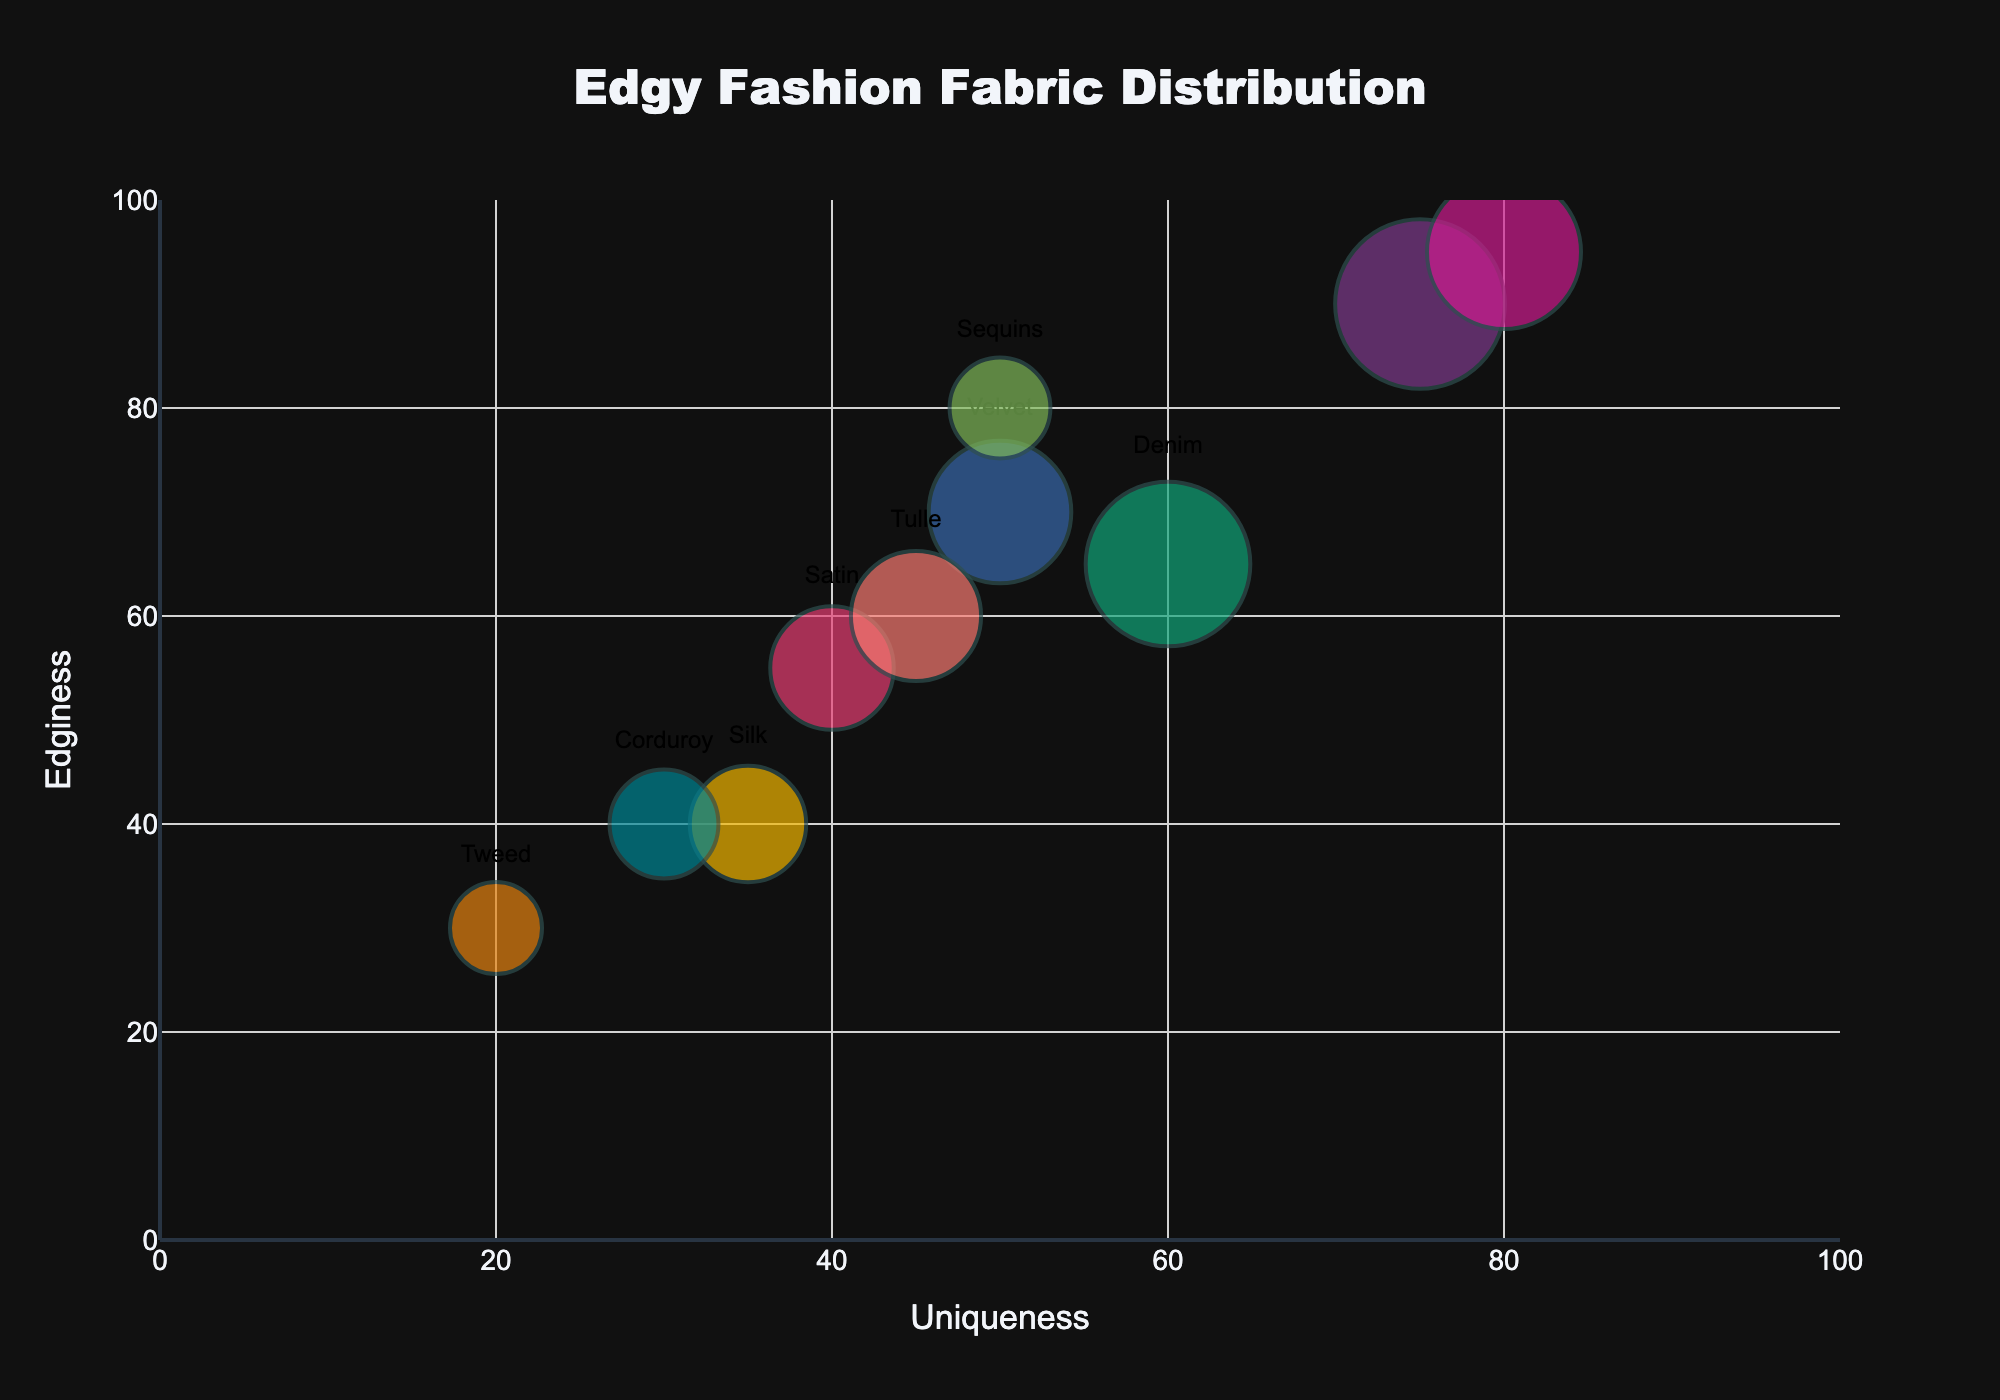what is the title of this Bubble Chart? The title is displayed prominently at the top center of the chart. It reads "Edgy Fashion Fabric Distribution".
Answer: Edgy Fashion Fabric Distribution how many fabrics are represented in this Bubble Chart? Count the number of unique bubbles in the chart. Each bubble represents a different fabric. There are 10 unique bubbles.
Answer: 10 which fabric has the highest popularity and what are its uniqueness and edginess values? Look for the largest bubble, as size indicates popularity. The largest bubble corresponds to Leather, with a popularity of 85, a uniqueness of 75, and an edginess of 90.
Answer: Leather, 75, 90 what is the average edginess value of the fabrics with a popularity greater than 50? Identify the fabrics with popularity values above 50: Leather, Denim, Velvet, Latex, and Tulle. Their edginess values are 90, 65, 70, 95, and 60 respectively. Calculate the average: (90 + 65 + 70 + 95 + 60) / 5 = 380 / 5 = 76.
Answer: 76 which fabric is less unique but more edgy than Denim? Find the bubble for Denim and note its uniqueness and edginess values: 60 and 65. Look for any bubble with a uniqueness less than 60 and an edginess more than 65. Sequins meets these criteria with a uniqueness of 50 and an edginess of 80.
Answer: Sequins how many fabrics have an edginess value greater than their uniqueness value? Compare the uniqueness and edginess values of all fabrics. Leather (75, 90), Sequins (50, 80), and Latex (80, 95) have edginess values greater than their uniqueness values. There are 3 such fabrics.
Answer: 3 which fabric with the lowest popularity has edginess and uniqueness values lower than 40? Identify the bubble with the smallest size, indicating the lowest popularity. Tweed has a popularity of 25, with edginess and uniqueness values of 30 and 20 respectively, both lower than 40.
Answer: Tweed is there any bubble that aligns with the same uniqueness and edginess value? Check if any two bubbles have the same uniqueness and edginess values. No bubbles have identical values for both attributes.
Answer: No which fabric has the same popularity level as Tulle but different uniqueness and edginess levels? Locate the fabric with the same popularity value as Tulle, which is 50. Tulle's uniqueness and edginess values are 45 and 60. No other fabric shares the same popularity level of 50.
Answer: No fabric where are the fabrics clustered around the 50 to 60 range on the uniqueness and edginess scales? Look at the bubbles positioned around the coordinates (50, 60). Velvet (60, 70), Silk (35, 40), Satin (40, 55), and Tulle (45, 60) are in the vicinity.
Answer: Velvet, Silk, Satin, Tulle 